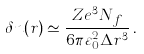Convert formula to latex. <formula><loc_0><loc_0><loc_500><loc_500>\delta n ( r ) \simeq \frac { Z e ^ { 3 } N _ { f } } { 6 \pi \varepsilon _ { 0 } ^ { 2 } \Delta r ^ { 3 } } \, .</formula> 